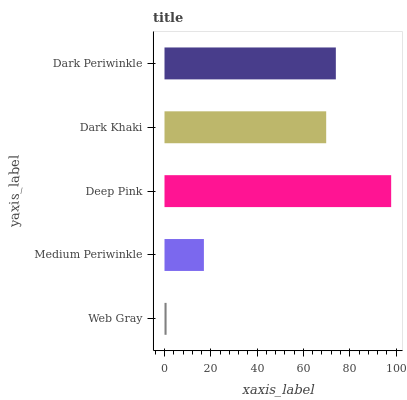Is Web Gray the minimum?
Answer yes or no. Yes. Is Deep Pink the maximum?
Answer yes or no. Yes. Is Medium Periwinkle the minimum?
Answer yes or no. No. Is Medium Periwinkle the maximum?
Answer yes or no. No. Is Medium Periwinkle greater than Web Gray?
Answer yes or no. Yes. Is Web Gray less than Medium Periwinkle?
Answer yes or no. Yes. Is Web Gray greater than Medium Periwinkle?
Answer yes or no. No. Is Medium Periwinkle less than Web Gray?
Answer yes or no. No. Is Dark Khaki the high median?
Answer yes or no. Yes. Is Dark Khaki the low median?
Answer yes or no. Yes. Is Dark Periwinkle the high median?
Answer yes or no. No. Is Web Gray the low median?
Answer yes or no. No. 